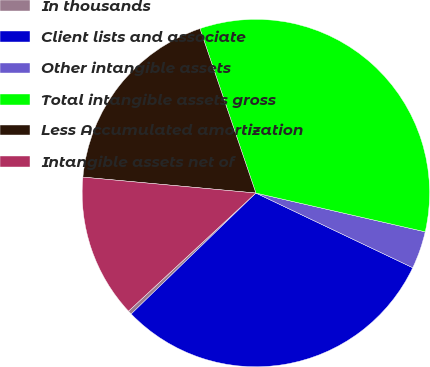Convert chart. <chart><loc_0><loc_0><loc_500><loc_500><pie_chart><fcel>In thousands<fcel>Client lists and associate<fcel>Other intangible assets<fcel>Total intangible assets gross<fcel>Less Accumulated amortization<fcel>Intangible assets net of<nl><fcel>0.36%<fcel>30.67%<fcel>3.49%<fcel>33.8%<fcel>18.32%<fcel>13.36%<nl></chart> 